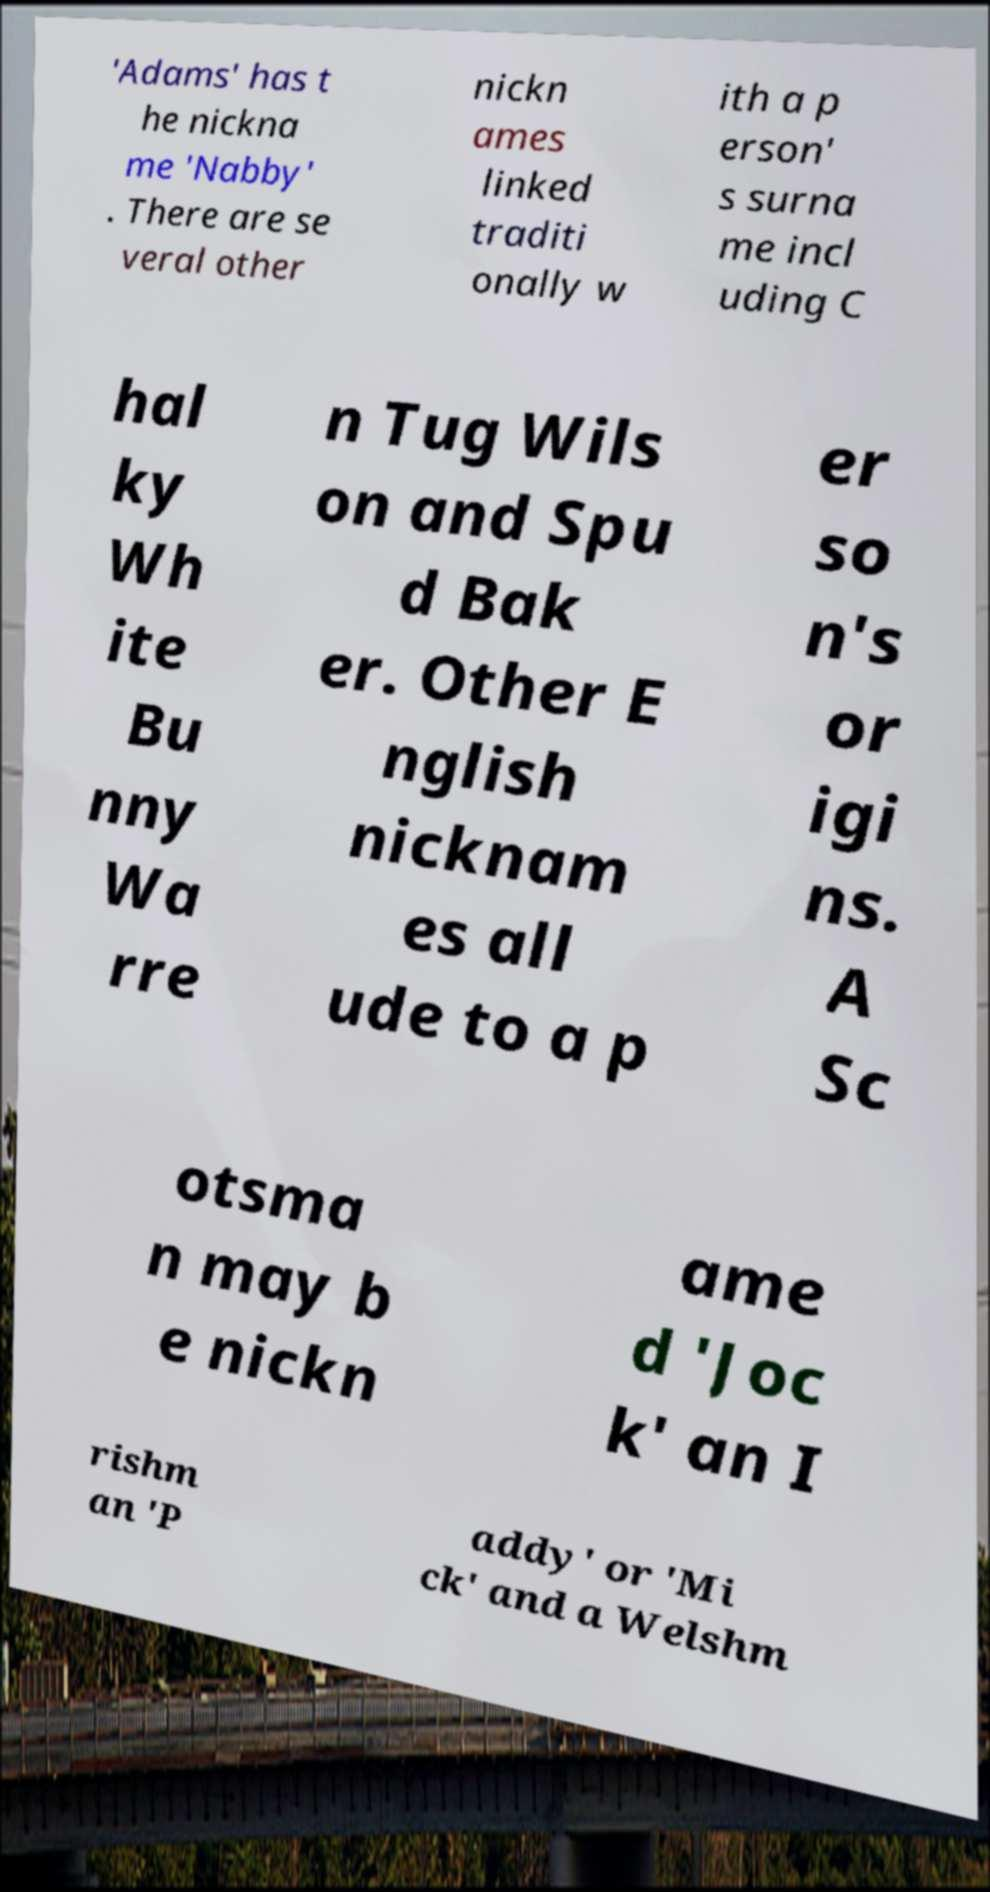Please identify and transcribe the text found in this image. 'Adams' has t he nickna me 'Nabby' . There are se veral other nickn ames linked traditi onally w ith a p erson' s surna me incl uding C hal ky Wh ite Bu nny Wa rre n Tug Wils on and Spu d Bak er. Other E nglish nicknam es all ude to a p er so n's or igi ns. A Sc otsma n may b e nickn ame d 'Joc k' an I rishm an 'P addy' or 'Mi ck' and a Welshm 